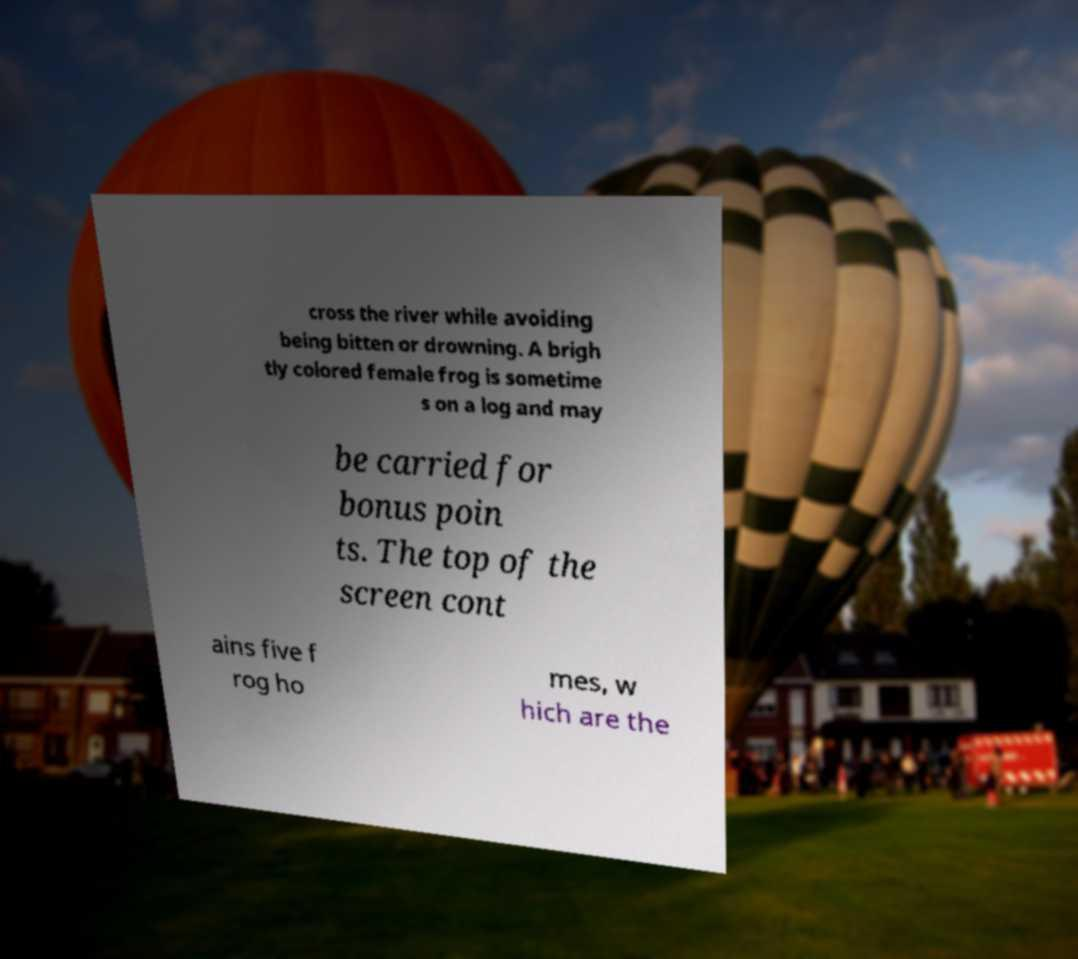Please read and relay the text visible in this image. What does it say? cross the river while avoiding being bitten or drowning. A brigh tly colored female frog is sometime s on a log and may be carried for bonus poin ts. The top of the screen cont ains five f rog ho mes, w hich are the 